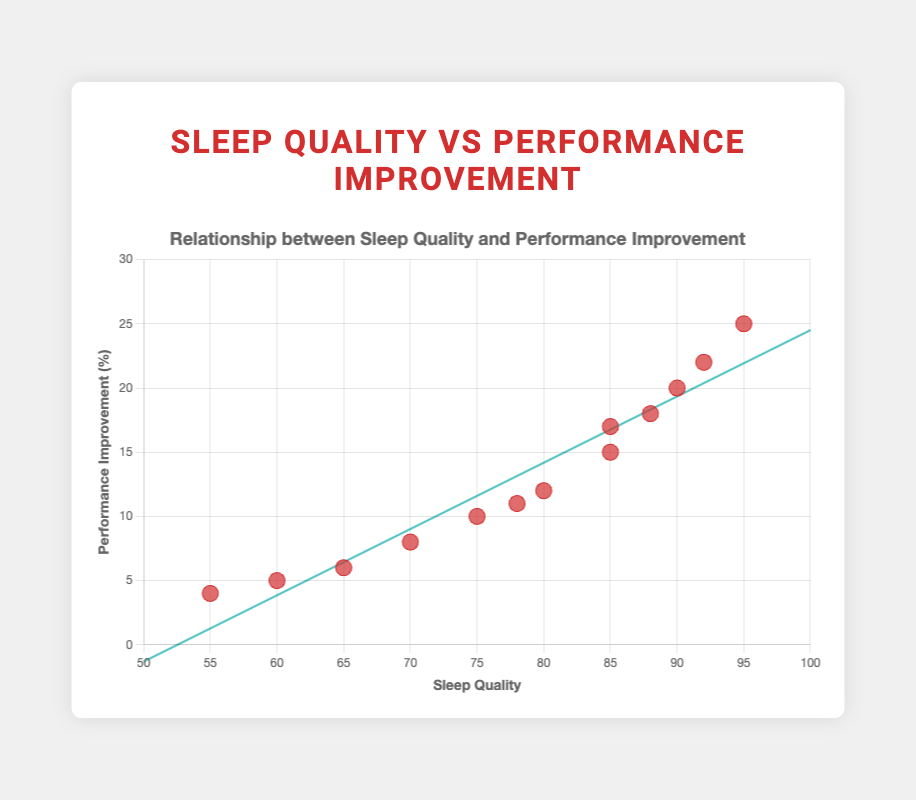What is the title of the scatter plot? The title of the scatter plot is usually displayed at the top of the chart. In this case, it is "Relationship between Sleep Quality and Performance Improvement."
Answer: Relationship between Sleep Quality and Performance Improvement What are the labels for the x and y axes? The labels for the axes are mentioned in the code: "Sleep Quality" for the x-axis and "Performance Improvement (%)" for the y-axis. These labels are typically displayed along the respective axes.
Answer: Sleep Quality (x-axis), Performance Improvement (%) (y-axis) How many data points are there in the figure? To count the number of data points, look at the number of entries in the dataset. There are 13 clients listed; hence, there are 13 data points.
Answer: 13 Which client has the highest sleep quality? To find the client with the highest sleep quality, we look for the data point with the highest x-value. Sarah Davis has a sleep quality of 95, which is the highest.
Answer: Sarah Davis What is the correlation between sleep quality and performance improvement based on the trend line? The trend line generally shows whether there's a positive or negative correlation. In this figure, the trend line has a positive slope, suggesting a positive correlation between sleep quality and performance improvement.
Answer: Positive correlation Which client showed the least performance improvement? To find the client with the least performance improvement, look for the data point with the lowest y-value, which is Daniel Thomas with an improvement of 4%.
Answer: Daniel Thomas Are there any clients with the same sleep quality but different performance improvements? Yes, there are. For instance, John Smith and Laura Moore both have a sleep quality of 85 but different performance improvements (15% and 17% respectively).
Answer: Yes What is the average sleep quality of the clients? Sum all the sleep quality values (85 + 90 + 75 + 80 + 70 + 95 + 65 + 85 + 60 + 92 + 55 + 88 + 78) which totals to 1118. Divide this by 13 clients to find the average: 1118 / 13 = 86.
Answer: 86 Compare the performance improvement between the clients with the highest and lowest sleep quality. Sarah Davis has the highest sleep quality of 95 with a performance improvement of 25%, and Daniel Thomas has the lowest sleep quality of 55 with a performance improvement of 4%.
Answer: Sarah Davis: 25%, Daniel Thomas: 4% What is the range of performance improvement values? The range is found by subtracting the smallest y-value from the largest y-value. The smallest performance improvement is 4% (Daniel Thomas), and the largest is 25% (Sarah Davis), so the range is 25% - 4% = 21%.
Answer: 21% 